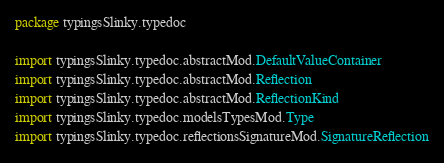Convert code to text. <code><loc_0><loc_0><loc_500><loc_500><_Scala_>package typingsSlinky.typedoc

import typingsSlinky.typedoc.abstractMod.DefaultValueContainer
import typingsSlinky.typedoc.abstractMod.Reflection
import typingsSlinky.typedoc.abstractMod.ReflectionKind
import typingsSlinky.typedoc.modelsTypesMod.Type
import typingsSlinky.typedoc.reflectionsSignatureMod.SignatureReflection</code> 